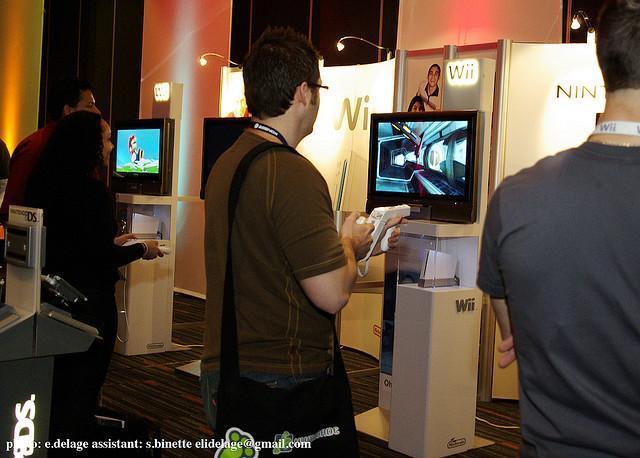How many screens?
Give a very brief answer. 2. How many tvs are visible?
Give a very brief answer. 2. How many people are there?
Give a very brief answer. 4. How many cars are waiting at the cross walk?
Give a very brief answer. 0. 